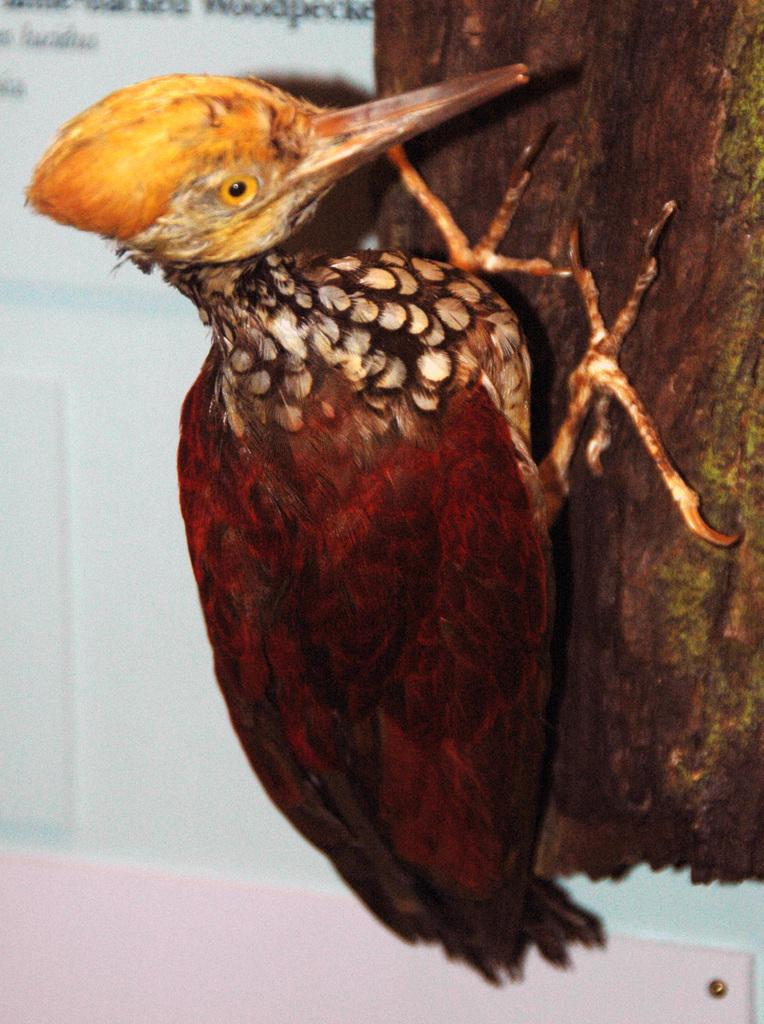What is the main subject in the foreground of the image? There is a bird in the foreground of the image. What can be seen on the right side of the image? There is a branch on the right side of the image. What is visible in the background of the image? There is a wall in the background of the image. How much profit does the bird make in the image? There is no mention of profit in the image, as it features a bird, a branch, and a wall. 